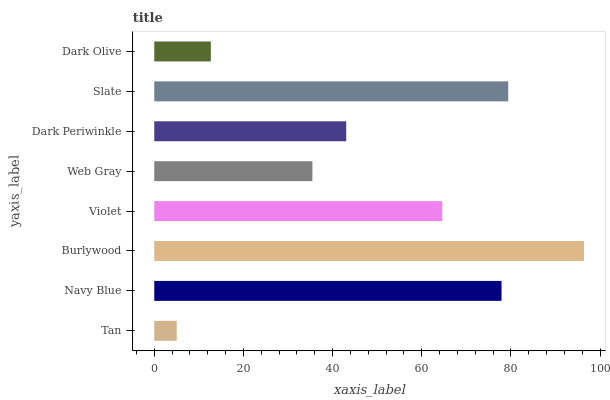Is Tan the minimum?
Answer yes or no. Yes. Is Burlywood the maximum?
Answer yes or no. Yes. Is Navy Blue the minimum?
Answer yes or no. No. Is Navy Blue the maximum?
Answer yes or no. No. Is Navy Blue greater than Tan?
Answer yes or no. Yes. Is Tan less than Navy Blue?
Answer yes or no. Yes. Is Tan greater than Navy Blue?
Answer yes or no. No. Is Navy Blue less than Tan?
Answer yes or no. No. Is Violet the high median?
Answer yes or no. Yes. Is Dark Periwinkle the low median?
Answer yes or no. Yes. Is Web Gray the high median?
Answer yes or no. No. Is Slate the low median?
Answer yes or no. No. 